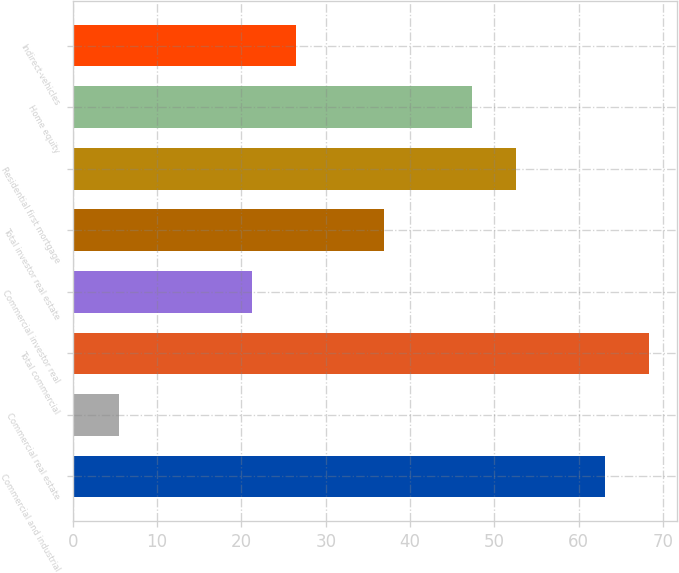Convert chart. <chart><loc_0><loc_0><loc_500><loc_500><bar_chart><fcel>Commercial and industrial<fcel>Commercial real estate<fcel>Total commercial<fcel>Commercial investor real<fcel>Total investor real estate<fcel>Residential first mortgage<fcel>Home equity<fcel>Indirect-vehicles<nl><fcel>63.06<fcel>5.53<fcel>68.29<fcel>21.22<fcel>36.91<fcel>52.6<fcel>47.37<fcel>26.45<nl></chart> 